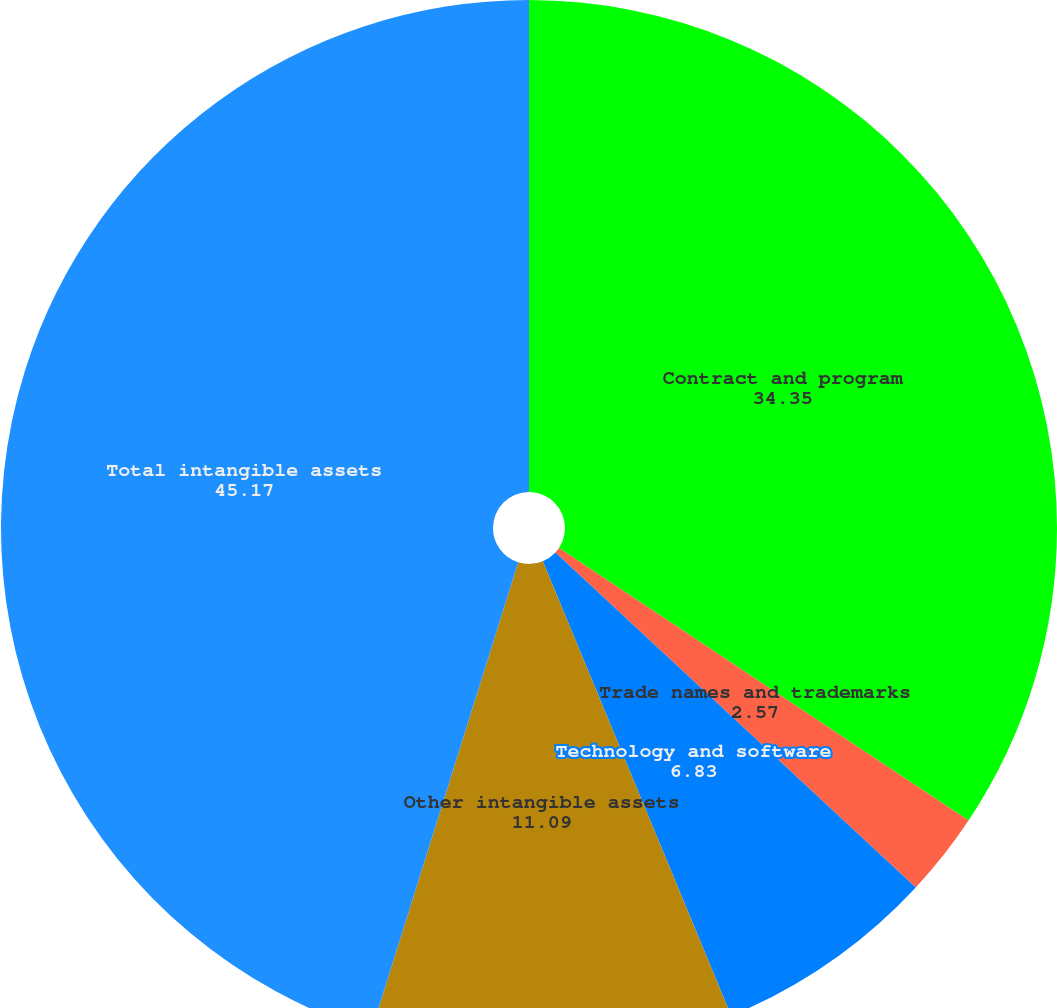Convert chart. <chart><loc_0><loc_0><loc_500><loc_500><pie_chart><fcel>Contract and program<fcel>Trade names and trademarks<fcel>Technology and software<fcel>Other intangible assets<fcel>Total intangible assets<nl><fcel>34.35%<fcel>2.57%<fcel>6.83%<fcel>11.09%<fcel>45.17%<nl></chart> 